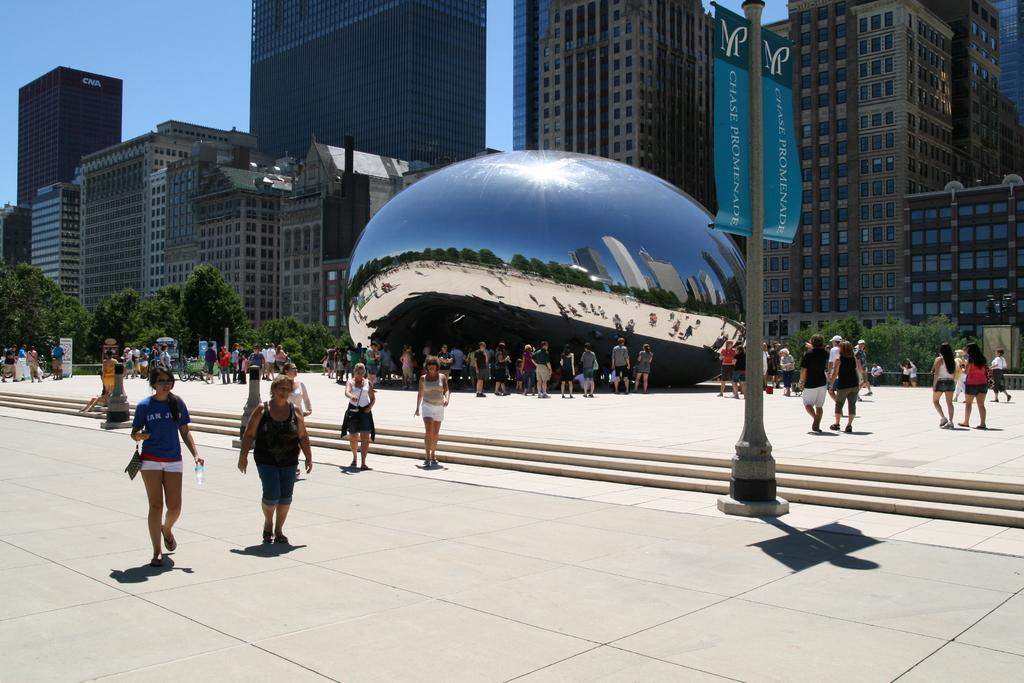In one or two sentences, can you explain what this image depicts? In front of the image there is a banner on the pole. There are people walking on the road. There are stairs. There is a sculpture. There are boards, trees, buildings. At the top of the image there is sky. 